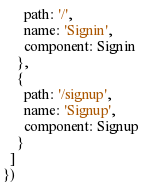Convert code to text. <code><loc_0><loc_0><loc_500><loc_500><_JavaScript_>      path: '/',
      name: 'Signin',
      component: Signin
    },
    {
      path: '/signup',
      name: 'Signup',
      component: Signup
    }
  ]
})
</code> 